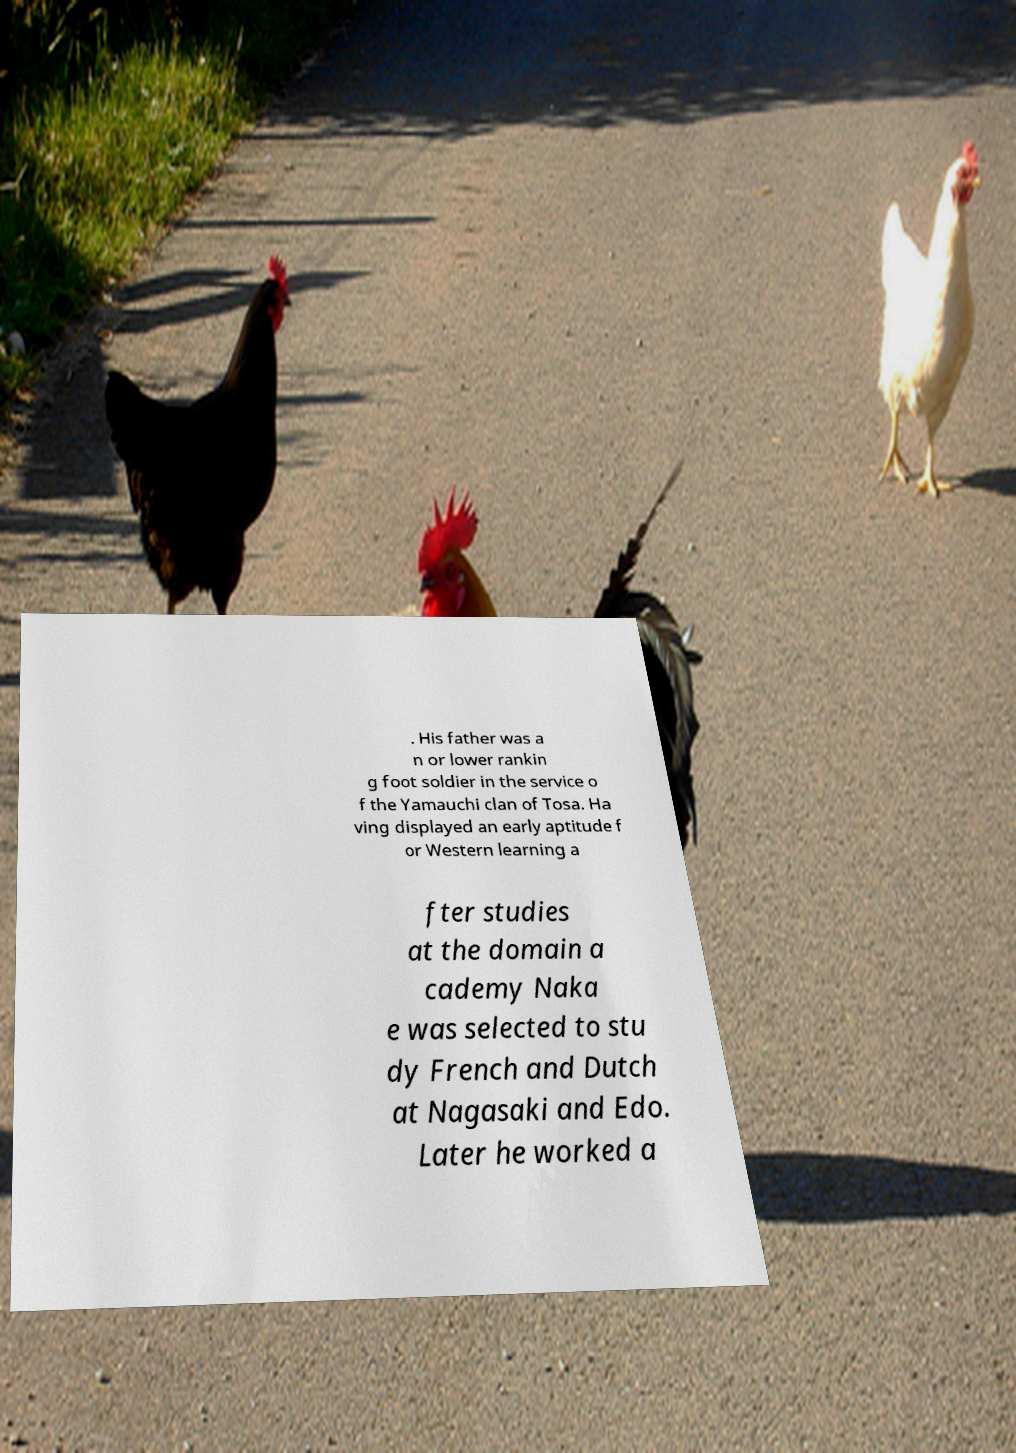What messages or text are displayed in this image? I need them in a readable, typed format. . His father was a n or lower rankin g foot soldier in the service o f the Yamauchi clan of Tosa. Ha ving displayed an early aptitude f or Western learning a fter studies at the domain a cademy Naka e was selected to stu dy French and Dutch at Nagasaki and Edo. Later he worked a 